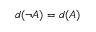<formula> <loc_0><loc_0><loc_500><loc_500>d ( \neg { A } ) = d ( A )</formula> 